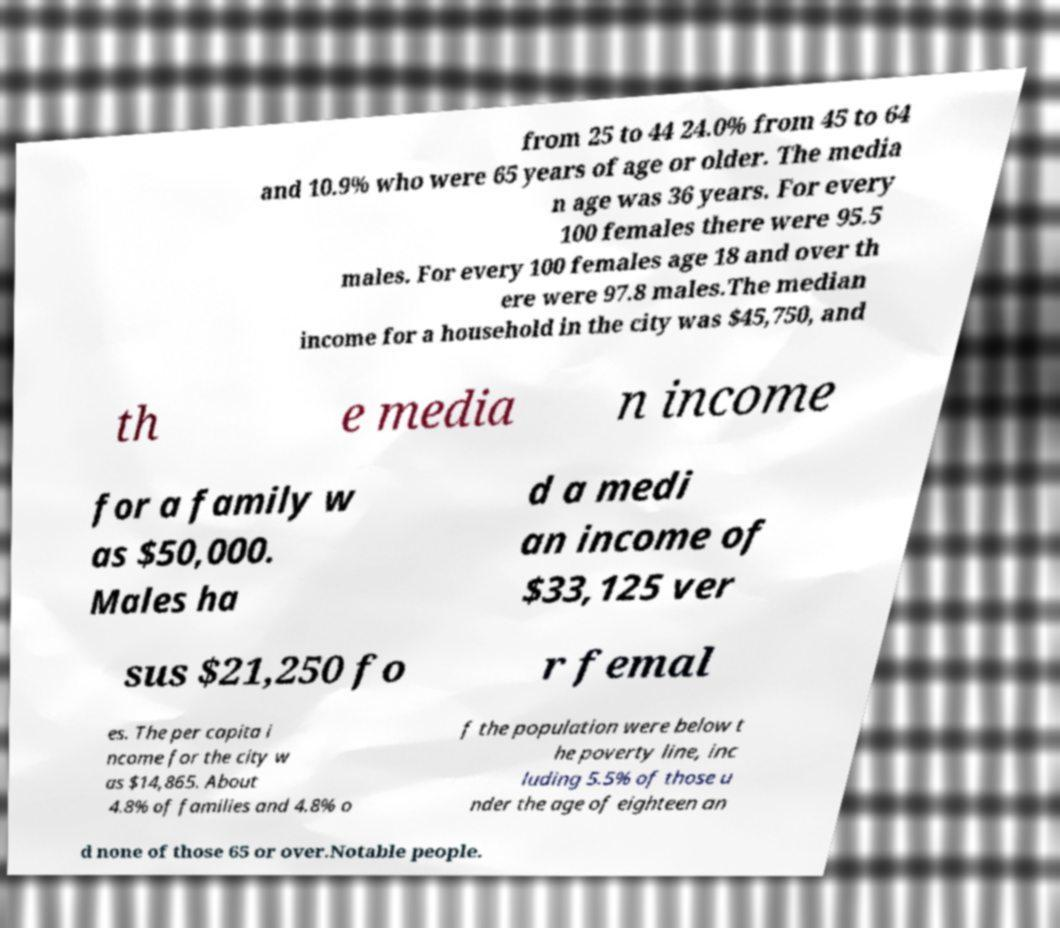Can you accurately transcribe the text from the provided image for me? from 25 to 44 24.0% from 45 to 64 and 10.9% who were 65 years of age or older. The media n age was 36 years. For every 100 females there were 95.5 males. For every 100 females age 18 and over th ere were 97.8 males.The median income for a household in the city was $45,750, and th e media n income for a family w as $50,000. Males ha d a medi an income of $33,125 ver sus $21,250 fo r femal es. The per capita i ncome for the city w as $14,865. About 4.8% of families and 4.8% o f the population were below t he poverty line, inc luding 5.5% of those u nder the age of eighteen an d none of those 65 or over.Notable people. 